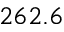Convert formula to latex. <formula><loc_0><loc_0><loc_500><loc_500>2 6 2 . 6</formula> 